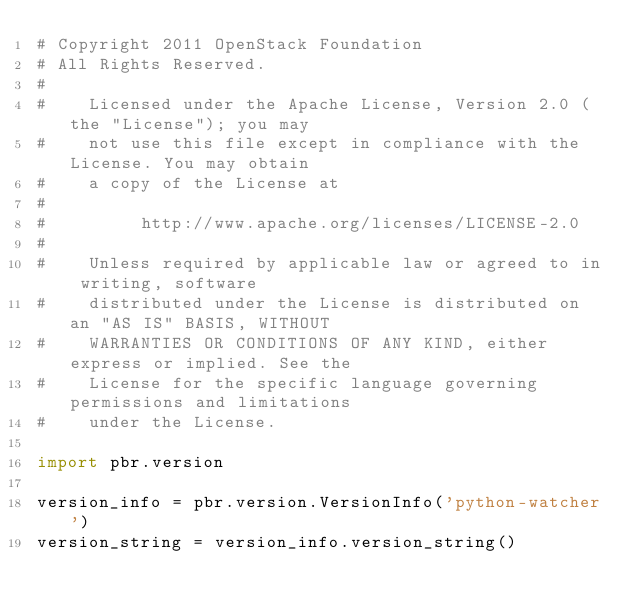Convert code to text. <code><loc_0><loc_0><loc_500><loc_500><_Python_># Copyright 2011 OpenStack Foundation
# All Rights Reserved.
#
#    Licensed under the Apache License, Version 2.0 (the "License"); you may
#    not use this file except in compliance with the License. You may obtain
#    a copy of the License at
#
#         http://www.apache.org/licenses/LICENSE-2.0
#
#    Unless required by applicable law or agreed to in writing, software
#    distributed under the License is distributed on an "AS IS" BASIS, WITHOUT
#    WARRANTIES OR CONDITIONS OF ANY KIND, either express or implied. See the
#    License for the specific language governing permissions and limitations
#    under the License.

import pbr.version

version_info = pbr.version.VersionInfo('python-watcher')
version_string = version_info.version_string()
</code> 